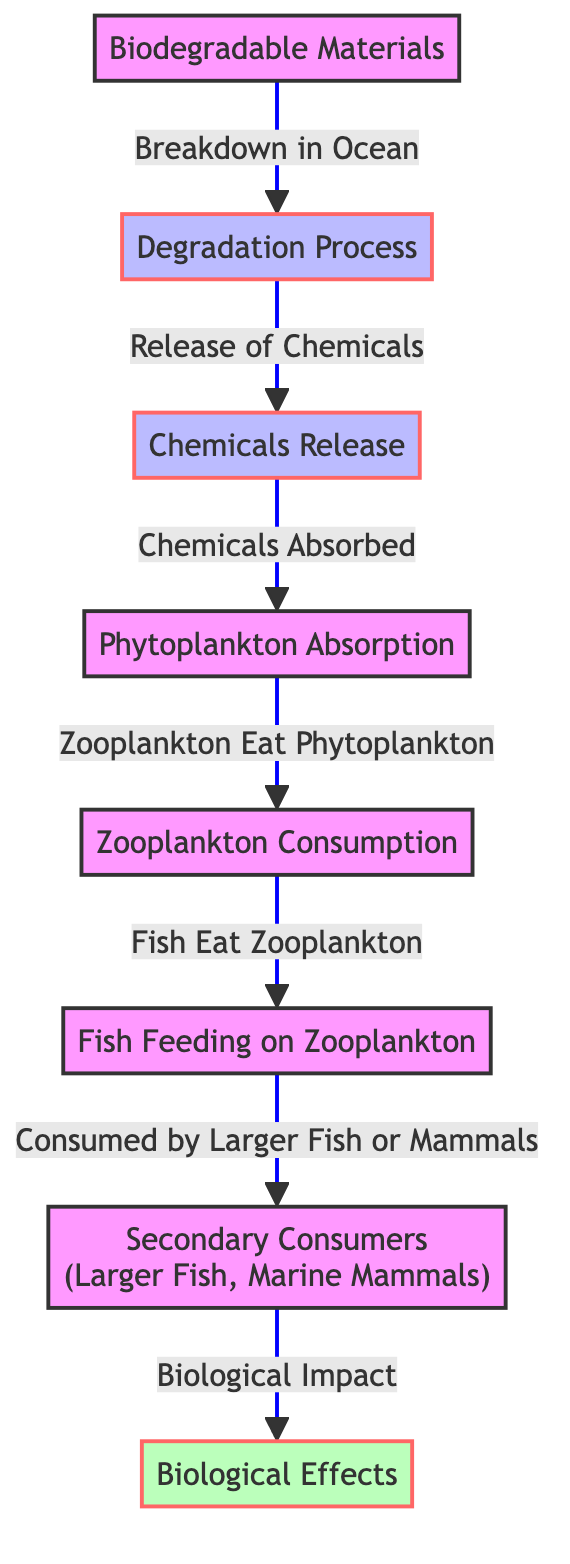What initiates the food chain in the diagram? The food chain in the diagram is initiated by the 'Biodegradable Materials', which are the starting point and contribute to the degradation process.
Answer: Biodegradable Materials What follows the Degradation Process in the diagram? After the 'Degradation Process', the next step is 'Chemicals Release', which indicates what happens as biodegradable materials break down.
Answer: Chemicals Release How many nodes are emphasized as effects in the diagram? There are two nodes specifically marked as effects; they are 'Biological Effects' and 'Secondary Consumers'.
Answer: 2 What consumes phytoplankton according to the diagram? 'Zooplankton' is indicated to consume phytoplankton, as seen in the flow from 'Phytoplankton Absorption' to 'Zooplankton Consumption'.
Answer: Zooplankton What is the final impact noted in the diagram? The final impact noted is 'Biological Effects', which represent the ultimate consequences on the ecological system due to the food chain processes.
Answer: Biological Effects Why is chemicals release significant in the diagram? 'Chemicals Release' is significant as it directly affects 'Phytoplankton Absorption', showing the importance of this step in the food chain dynamics.
Answer: Chemicals Release What do secondary consumers feed on as per the diagram? 'Secondary Consumers' feed on 'Fish', as indicated by the flow from 'Fish Feeding on Zooplankton' to 'Secondary Consumers'.
Answer: Fish What links phytoplankton absorption to biological effects? The flow from 'Phytoplankton Absorption' through 'Zooplankton Consumption', 'Fish Feeding', and 'Secondary Consumers' ultimately links to 'Biological Effects'.
Answer: Zooplankton Consumption, Fish Feeding, Secondary Consumers How does the diagram illustrate the interaction between various marine organisms? The diagram illustrates interactions via the flows between nodes, showing that biodegradable materials affect phytoplankton which then impacts zooplankton, fish, and subsequently larger marine predators.
Answer: Various flows of interaction 